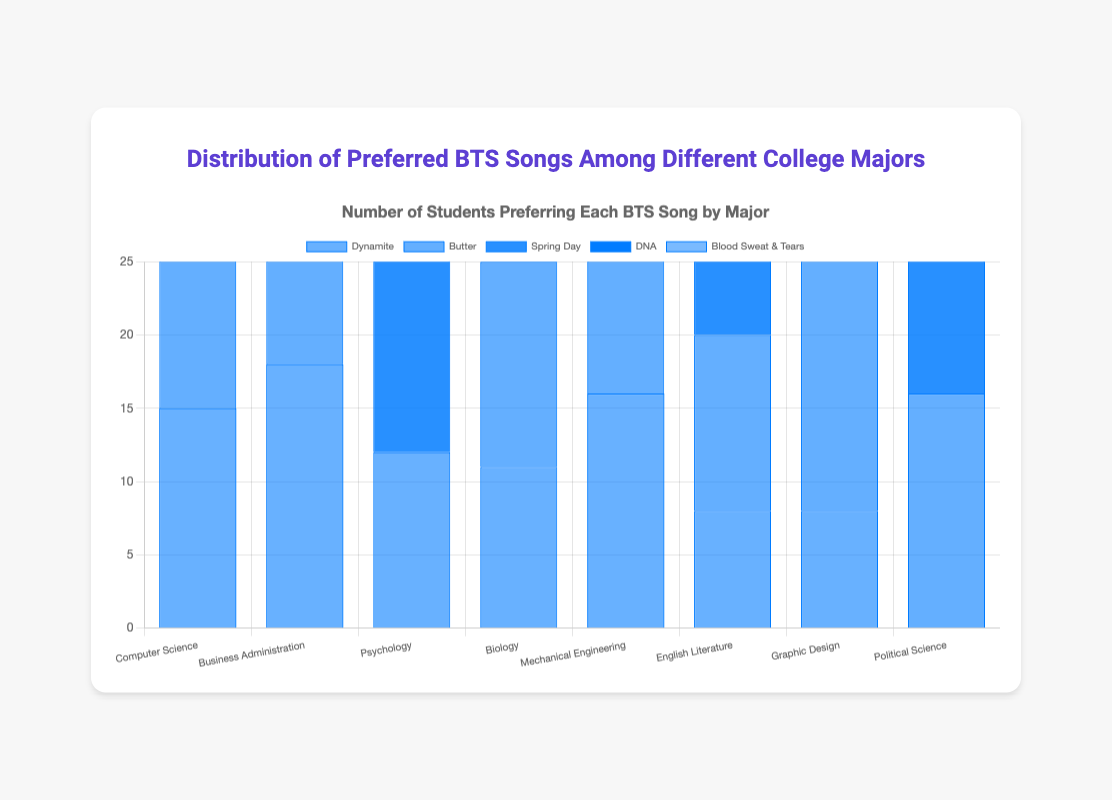Which college major prefers "Butter" the most? Look at the height of the "Butter" bars across all majors. The tallest bar for "Butter" is under Business Administration.
Answer: Business Administration Which song is the least preferred by Biology majors? Check the heights of all bars under Biology. The shortest bar under Biology belongs to "Fake Love".
Answer: Fake Love How many total preferences are there for "Dynamite" across all majors? Sum the heights of the "Dynamite" bars across all majors: 15 (CS) + 18 (BA) + 12 (Psych) + 11 (Bio) + 16 (ME) + 8 (Eng Lit) + 8 (GD) + 0 (PS) = 88
Answer: 88 Which song is preferred more by Computer Science majors, "Spring Day" or "Blood Sweat & Tears"? Compare the heights of the "Spring Day" and "Blood Sweat & Tears" bars. "Spring Day" has a height of 10, and "Blood Sweat & Tears" has a height of 8.
Answer: Spring Day What is the average preference for "Spring Day" among Psychology, Biology, and Political Science majors? Calculate the average by adding the preferences and dividing by 3: (20 (Psych) + 18 (Bio) + 12 (PS)) / 3 = 50 / 3 ≈ 16.67
Answer: 16.67 Which major has the highest preference for "Blood Sweat & Tears"? Look for the major with the tallest "Blood Sweat & Tears" bar. The tallest bar is under Graphic Design.
Answer: Graphic Design How many more students prefer "Butter" than "Dynamite" among Business Administration majors? Subtract the "Dynamite" preference from the "Butter" preference in Business Administration: 22 (Butter) - 18 (Dynamite) = 4
Answer: 4 Which song has the smallest total preference across all majors? Sum the preferences for each song across all majors and find the smallest total. "Mic Drop": 12+0+0+0+8+12+0+0=32; "Fake Love": 0+0+0+7+0+0+0+6=13; "Boy With Luv": 0+8+0+9+0+0+10+0=27; "DNA": 5+0+0+0+0+0+18+0=23; "Not Today": 0+0+0+0+0+0+0+14=14; "Save Me": 0+0+8+0+0+0+0+0=8; "Idol": 0+0+0+0+14+0+0+10=24; "Epiphany": 0+0+10+0+0+10+0+0=20. "Save Me" has the smallest total preference.
Answer: Save Me In which major is "Dynamite" less popular than "Spring Day"? Check where the "Dynamite" bar is shorter than the "Spring Day" bar. This occurs in Psychology, Biology, and English Literature.
Answer: Psychology, Biology, English Literature 